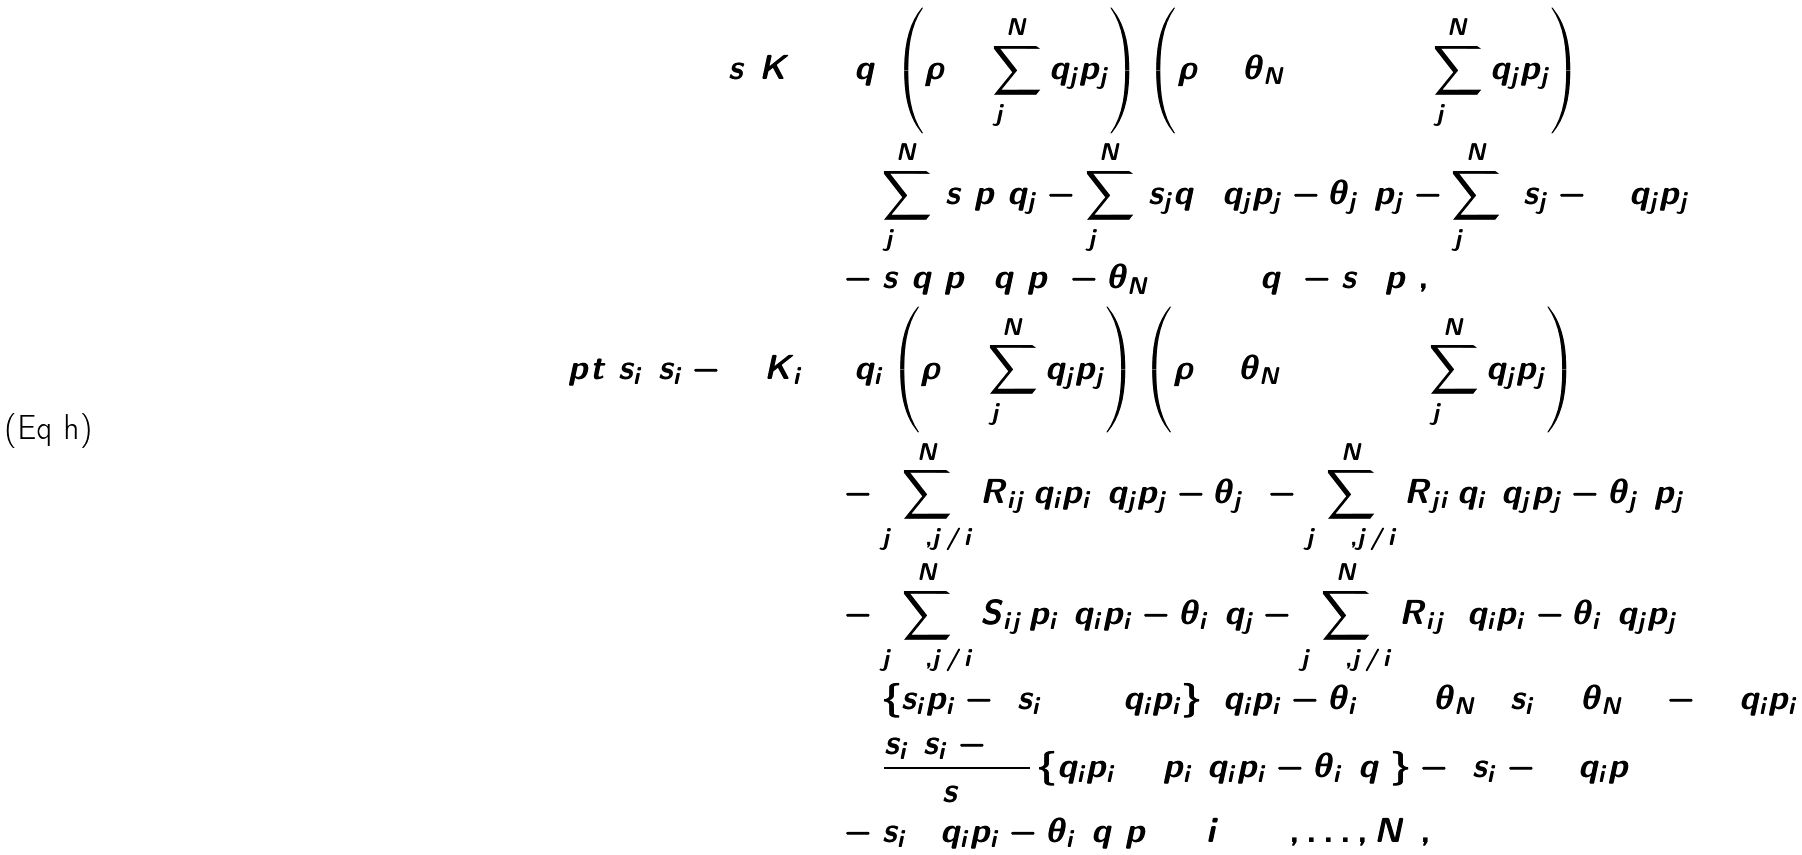Convert formula to latex. <formula><loc_0><loc_0><loc_500><loc_500>s _ { 1 } ^ { 2 } K _ { 1 } & = q _ { 1 } \left ( \rho + \sum _ { j = 1 } ^ { N } q _ { j } p _ { j } \right ) \left ( \rho + \theta _ { N + 3 } + 1 + \sum _ { j = 1 } ^ { N } q _ { j } p _ { j } \right ) \\ & \quad + \sum _ { j = 2 } ^ { N } \, s _ { 1 } p _ { 1 } q _ { j } - \sum _ { j = 2 } ^ { N } \, s _ { j } q _ { 1 } ( q _ { j } p _ { j } - \theta _ { j } ) p _ { j } - \sum _ { j = 2 } ^ { N } \, ( s _ { j } - 1 ) q _ { j } p _ { j } \\ & \quad - s _ { 1 } q _ { 1 } p _ { 1 } ( q _ { 1 } p _ { 1 } - \theta _ { N + 2 } ) + ( q _ { 1 } - s _ { 1 } ) p _ { 1 } , \\ [ 4 p t ] s _ { i } ( s _ { i } - 1 ) K _ { i } & = q _ { i } \left ( \rho + \sum _ { j = 1 } ^ { N } q _ { j } p _ { j } \right ) \left ( \rho + \theta _ { N + 3 } + 1 + \sum _ { j = 1 } ^ { N } q _ { j } p _ { j } \right ) \\ & \quad - \sum _ { j = 2 , j \neq i } ^ { N } R _ { i j } \, q _ { i } p _ { i } ( q _ { j } p _ { j } - \theta _ { j } ) - \sum _ { j = 2 , j \neq i } ^ { N } R _ { j i } \, q _ { i } ( q _ { j } p _ { j } - \theta _ { j } ) p _ { j } \\ & \quad - \sum _ { j = 2 , j \neq i } ^ { N } S _ { i j } \, p _ { i } ( q _ { i } p _ { i } - \theta _ { i } ) q _ { j } - \sum _ { j = 2 , j \neq i } ^ { N } R _ { i j } \, ( q _ { i } p _ { i } - \theta _ { i } ) q _ { j } p _ { j } \\ & \quad + \left \{ s _ { i } p _ { i } - ( s _ { i } + 1 ) q _ { i } p _ { i } \right \} ( q _ { i } p _ { i } - \theta _ { i } ) + ( \theta _ { N + 2 } s _ { i } + \theta _ { N + 1 } - 1 ) q _ { i } p _ { i } \\ & \quad + \frac { s _ { i } ( s _ { i } - 1 ) } { s _ { 1 } } \left \{ q _ { i } p _ { i } + p _ { i } ( q _ { i } p _ { i } - \theta _ { i } ) q _ { 1 } \right \} - ( s _ { i } - 1 ) q _ { i } p _ { 1 } \\ & \quad - s _ { i } ( 2 q _ { i } p _ { i } - \theta _ { i } ) q _ { 1 } p _ { 1 } \quad ( i = 2 , \dots , N ) ,</formula> 